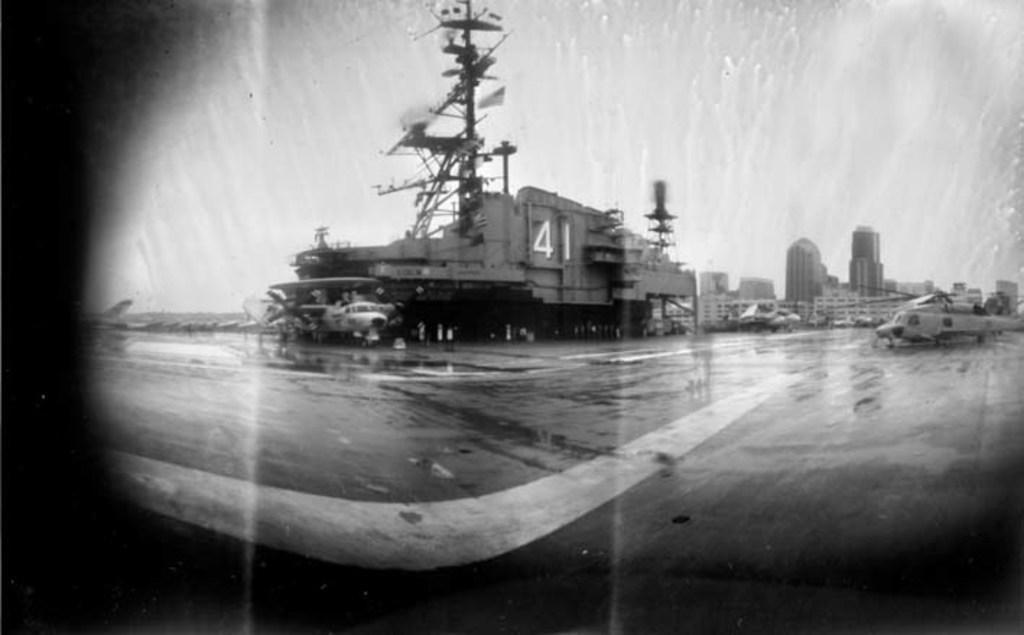How would you summarize this image in a sentence or two? In this image we can see some air crafts, there are buildings, towers, also we can see the sky and the picture is taken in black and white mode. 